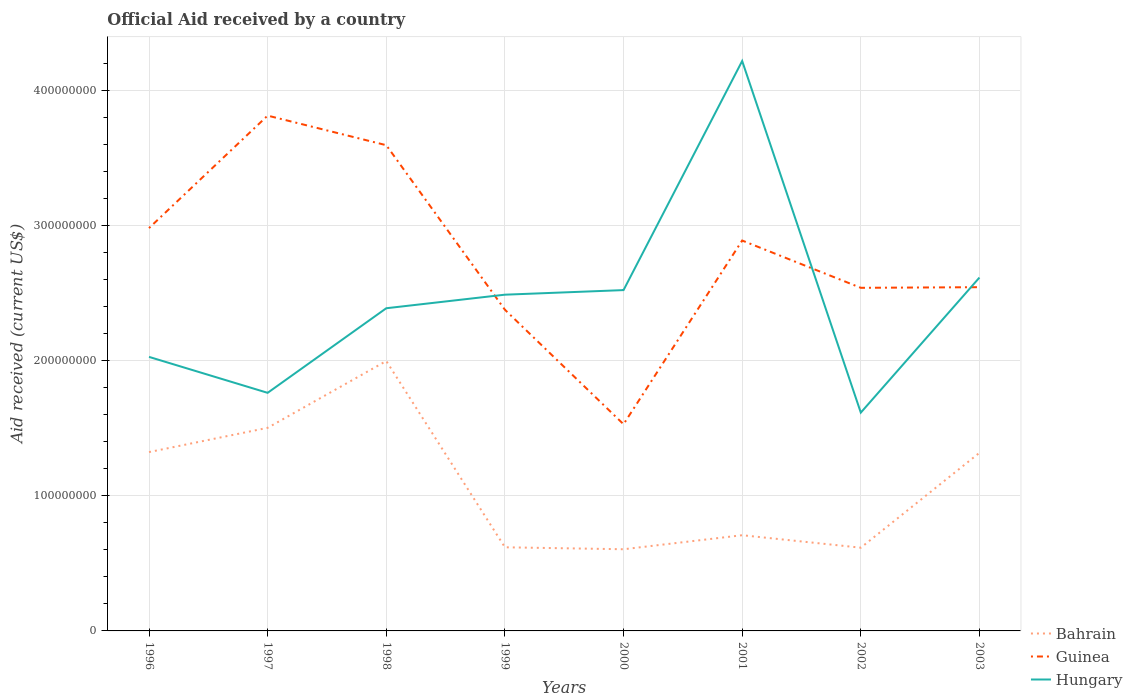How many different coloured lines are there?
Give a very brief answer. 3. Is the number of lines equal to the number of legend labels?
Give a very brief answer. Yes. Across all years, what is the maximum net official aid received in Guinea?
Give a very brief answer. 1.53e+08. In which year was the net official aid received in Guinea maximum?
Provide a short and direct response. 2000. What is the total net official aid received in Guinea in the graph?
Ensure brevity in your answer.  6.04e+07. What is the difference between the highest and the second highest net official aid received in Bahrain?
Make the answer very short. 1.39e+08. How many years are there in the graph?
Offer a very short reply. 8. What is the difference between two consecutive major ticks on the Y-axis?
Keep it short and to the point. 1.00e+08. Are the values on the major ticks of Y-axis written in scientific E-notation?
Make the answer very short. No. How many legend labels are there?
Offer a very short reply. 3. How are the legend labels stacked?
Offer a very short reply. Vertical. What is the title of the graph?
Your answer should be very brief. Official Aid received by a country. Does "New Caledonia" appear as one of the legend labels in the graph?
Ensure brevity in your answer.  No. What is the label or title of the Y-axis?
Provide a short and direct response. Aid received (current US$). What is the Aid received (current US$) of Bahrain in 1996?
Offer a terse response. 1.32e+08. What is the Aid received (current US$) of Guinea in 1996?
Your answer should be very brief. 2.98e+08. What is the Aid received (current US$) in Hungary in 1996?
Make the answer very short. 2.03e+08. What is the Aid received (current US$) of Bahrain in 1997?
Provide a succinct answer. 1.50e+08. What is the Aid received (current US$) of Guinea in 1997?
Keep it short and to the point. 3.81e+08. What is the Aid received (current US$) in Hungary in 1997?
Provide a short and direct response. 1.76e+08. What is the Aid received (current US$) in Bahrain in 1998?
Your response must be concise. 2.00e+08. What is the Aid received (current US$) in Guinea in 1998?
Offer a terse response. 3.59e+08. What is the Aid received (current US$) of Hungary in 1998?
Make the answer very short. 2.39e+08. What is the Aid received (current US$) in Bahrain in 1999?
Keep it short and to the point. 6.19e+07. What is the Aid received (current US$) in Guinea in 1999?
Give a very brief answer. 2.38e+08. What is the Aid received (current US$) in Hungary in 1999?
Make the answer very short. 2.49e+08. What is the Aid received (current US$) in Bahrain in 2000?
Your answer should be very brief. 6.04e+07. What is the Aid received (current US$) in Guinea in 2000?
Your answer should be very brief. 1.53e+08. What is the Aid received (current US$) in Hungary in 2000?
Your answer should be very brief. 2.52e+08. What is the Aid received (current US$) in Bahrain in 2001?
Keep it short and to the point. 7.08e+07. What is the Aid received (current US$) in Guinea in 2001?
Keep it short and to the point. 2.89e+08. What is the Aid received (current US$) in Hungary in 2001?
Provide a short and direct response. 4.22e+08. What is the Aid received (current US$) in Bahrain in 2002?
Your response must be concise. 6.16e+07. What is the Aid received (current US$) of Guinea in 2002?
Provide a succinct answer. 2.54e+08. What is the Aid received (current US$) in Hungary in 2002?
Make the answer very short. 1.62e+08. What is the Aid received (current US$) in Bahrain in 2003?
Offer a very short reply. 1.32e+08. What is the Aid received (current US$) of Guinea in 2003?
Offer a terse response. 2.54e+08. What is the Aid received (current US$) in Hungary in 2003?
Your response must be concise. 2.61e+08. Across all years, what is the maximum Aid received (current US$) in Bahrain?
Provide a succinct answer. 2.00e+08. Across all years, what is the maximum Aid received (current US$) in Guinea?
Offer a very short reply. 3.81e+08. Across all years, what is the maximum Aid received (current US$) in Hungary?
Your answer should be very brief. 4.22e+08. Across all years, what is the minimum Aid received (current US$) in Bahrain?
Ensure brevity in your answer.  6.04e+07. Across all years, what is the minimum Aid received (current US$) of Guinea?
Your response must be concise. 1.53e+08. Across all years, what is the minimum Aid received (current US$) of Hungary?
Provide a short and direct response. 1.62e+08. What is the total Aid received (current US$) in Bahrain in the graph?
Ensure brevity in your answer.  8.69e+08. What is the total Aid received (current US$) in Guinea in the graph?
Offer a terse response. 2.23e+09. What is the total Aid received (current US$) of Hungary in the graph?
Your answer should be compact. 1.96e+09. What is the difference between the Aid received (current US$) in Bahrain in 1996 and that in 1997?
Make the answer very short. -1.80e+07. What is the difference between the Aid received (current US$) of Guinea in 1996 and that in 1997?
Your response must be concise. -8.32e+07. What is the difference between the Aid received (current US$) of Hungary in 1996 and that in 1997?
Keep it short and to the point. 2.66e+07. What is the difference between the Aid received (current US$) in Bahrain in 1996 and that in 1998?
Give a very brief answer. -6.74e+07. What is the difference between the Aid received (current US$) in Guinea in 1996 and that in 1998?
Give a very brief answer. -6.13e+07. What is the difference between the Aid received (current US$) in Hungary in 1996 and that in 1998?
Give a very brief answer. -3.60e+07. What is the difference between the Aid received (current US$) in Bahrain in 1996 and that in 1999?
Give a very brief answer. 7.04e+07. What is the difference between the Aid received (current US$) in Guinea in 1996 and that in 1999?
Ensure brevity in your answer.  6.04e+07. What is the difference between the Aid received (current US$) of Hungary in 1996 and that in 1999?
Your answer should be compact. -4.60e+07. What is the difference between the Aid received (current US$) of Bahrain in 1996 and that in 2000?
Offer a terse response. 7.19e+07. What is the difference between the Aid received (current US$) of Guinea in 1996 and that in 2000?
Make the answer very short. 1.45e+08. What is the difference between the Aid received (current US$) in Hungary in 1996 and that in 2000?
Provide a short and direct response. -4.94e+07. What is the difference between the Aid received (current US$) of Bahrain in 1996 and that in 2001?
Make the answer very short. 6.15e+07. What is the difference between the Aid received (current US$) in Guinea in 1996 and that in 2001?
Offer a very short reply. 9.21e+06. What is the difference between the Aid received (current US$) of Hungary in 1996 and that in 2001?
Provide a succinct answer. -2.19e+08. What is the difference between the Aid received (current US$) in Bahrain in 1996 and that in 2002?
Offer a terse response. 7.07e+07. What is the difference between the Aid received (current US$) in Guinea in 1996 and that in 2002?
Make the answer very short. 4.42e+07. What is the difference between the Aid received (current US$) of Hungary in 1996 and that in 2002?
Give a very brief answer. 4.12e+07. What is the difference between the Aid received (current US$) of Guinea in 1996 and that in 2003?
Your answer should be very brief. 4.37e+07. What is the difference between the Aid received (current US$) of Hungary in 1996 and that in 2003?
Your response must be concise. -5.87e+07. What is the difference between the Aid received (current US$) in Bahrain in 1997 and that in 1998?
Provide a short and direct response. -4.94e+07. What is the difference between the Aid received (current US$) in Guinea in 1997 and that in 1998?
Make the answer very short. 2.19e+07. What is the difference between the Aid received (current US$) in Hungary in 1997 and that in 1998?
Offer a terse response. -6.26e+07. What is the difference between the Aid received (current US$) of Bahrain in 1997 and that in 1999?
Give a very brief answer. 8.84e+07. What is the difference between the Aid received (current US$) of Guinea in 1997 and that in 1999?
Keep it short and to the point. 1.44e+08. What is the difference between the Aid received (current US$) of Hungary in 1997 and that in 1999?
Make the answer very short. -7.26e+07. What is the difference between the Aid received (current US$) in Bahrain in 1997 and that in 2000?
Keep it short and to the point. 8.98e+07. What is the difference between the Aid received (current US$) in Guinea in 1997 and that in 2000?
Give a very brief answer. 2.28e+08. What is the difference between the Aid received (current US$) of Hungary in 1997 and that in 2000?
Provide a short and direct response. -7.60e+07. What is the difference between the Aid received (current US$) in Bahrain in 1997 and that in 2001?
Keep it short and to the point. 7.95e+07. What is the difference between the Aid received (current US$) in Guinea in 1997 and that in 2001?
Provide a succinct answer. 9.24e+07. What is the difference between the Aid received (current US$) in Hungary in 1997 and that in 2001?
Offer a terse response. -2.46e+08. What is the difference between the Aid received (current US$) of Bahrain in 1997 and that in 2002?
Your response must be concise. 8.87e+07. What is the difference between the Aid received (current US$) in Guinea in 1997 and that in 2002?
Your answer should be very brief. 1.27e+08. What is the difference between the Aid received (current US$) in Hungary in 1997 and that in 2002?
Ensure brevity in your answer.  1.46e+07. What is the difference between the Aid received (current US$) in Bahrain in 1997 and that in 2003?
Your answer should be very brief. 1.85e+07. What is the difference between the Aid received (current US$) of Guinea in 1997 and that in 2003?
Offer a terse response. 1.27e+08. What is the difference between the Aid received (current US$) of Hungary in 1997 and that in 2003?
Your answer should be very brief. -8.53e+07. What is the difference between the Aid received (current US$) in Bahrain in 1998 and that in 1999?
Offer a terse response. 1.38e+08. What is the difference between the Aid received (current US$) of Guinea in 1998 and that in 1999?
Give a very brief answer. 1.22e+08. What is the difference between the Aid received (current US$) in Hungary in 1998 and that in 1999?
Your answer should be very brief. -1.00e+07. What is the difference between the Aid received (current US$) in Bahrain in 1998 and that in 2000?
Provide a succinct answer. 1.39e+08. What is the difference between the Aid received (current US$) of Guinea in 1998 and that in 2000?
Keep it short and to the point. 2.06e+08. What is the difference between the Aid received (current US$) of Hungary in 1998 and that in 2000?
Make the answer very short. -1.34e+07. What is the difference between the Aid received (current US$) in Bahrain in 1998 and that in 2001?
Keep it short and to the point. 1.29e+08. What is the difference between the Aid received (current US$) of Guinea in 1998 and that in 2001?
Give a very brief answer. 7.05e+07. What is the difference between the Aid received (current US$) of Hungary in 1998 and that in 2001?
Make the answer very short. -1.83e+08. What is the difference between the Aid received (current US$) of Bahrain in 1998 and that in 2002?
Provide a short and direct response. 1.38e+08. What is the difference between the Aid received (current US$) in Guinea in 1998 and that in 2002?
Offer a very short reply. 1.06e+08. What is the difference between the Aid received (current US$) in Hungary in 1998 and that in 2002?
Your answer should be compact. 7.72e+07. What is the difference between the Aid received (current US$) of Bahrain in 1998 and that in 2003?
Your response must be concise. 6.80e+07. What is the difference between the Aid received (current US$) in Guinea in 1998 and that in 2003?
Provide a succinct answer. 1.05e+08. What is the difference between the Aid received (current US$) of Hungary in 1998 and that in 2003?
Offer a terse response. -2.27e+07. What is the difference between the Aid received (current US$) in Bahrain in 1999 and that in 2000?
Offer a very short reply. 1.45e+06. What is the difference between the Aid received (current US$) in Guinea in 1999 and that in 2000?
Your answer should be very brief. 8.47e+07. What is the difference between the Aid received (current US$) in Hungary in 1999 and that in 2000?
Make the answer very short. -3.39e+06. What is the difference between the Aid received (current US$) in Bahrain in 1999 and that in 2001?
Provide a short and direct response. -8.93e+06. What is the difference between the Aid received (current US$) in Guinea in 1999 and that in 2001?
Provide a short and direct response. -5.12e+07. What is the difference between the Aid received (current US$) of Hungary in 1999 and that in 2001?
Ensure brevity in your answer.  -1.73e+08. What is the difference between the Aid received (current US$) in Bahrain in 1999 and that in 2002?
Make the answer very short. 3.00e+05. What is the difference between the Aid received (current US$) of Guinea in 1999 and that in 2002?
Ensure brevity in your answer.  -1.62e+07. What is the difference between the Aid received (current US$) of Hungary in 1999 and that in 2002?
Keep it short and to the point. 8.73e+07. What is the difference between the Aid received (current US$) in Bahrain in 1999 and that in 2003?
Keep it short and to the point. -6.99e+07. What is the difference between the Aid received (current US$) in Guinea in 1999 and that in 2003?
Ensure brevity in your answer.  -1.67e+07. What is the difference between the Aid received (current US$) of Hungary in 1999 and that in 2003?
Keep it short and to the point. -1.27e+07. What is the difference between the Aid received (current US$) in Bahrain in 2000 and that in 2001?
Ensure brevity in your answer.  -1.04e+07. What is the difference between the Aid received (current US$) in Guinea in 2000 and that in 2001?
Keep it short and to the point. -1.36e+08. What is the difference between the Aid received (current US$) in Hungary in 2000 and that in 2001?
Your answer should be very brief. -1.70e+08. What is the difference between the Aid received (current US$) in Bahrain in 2000 and that in 2002?
Make the answer very short. -1.15e+06. What is the difference between the Aid received (current US$) in Guinea in 2000 and that in 2002?
Make the answer very short. -1.01e+08. What is the difference between the Aid received (current US$) of Hungary in 2000 and that in 2002?
Ensure brevity in your answer.  9.06e+07. What is the difference between the Aid received (current US$) of Bahrain in 2000 and that in 2003?
Provide a succinct answer. -7.13e+07. What is the difference between the Aid received (current US$) in Guinea in 2000 and that in 2003?
Provide a succinct answer. -1.01e+08. What is the difference between the Aid received (current US$) of Hungary in 2000 and that in 2003?
Your answer should be very brief. -9.28e+06. What is the difference between the Aid received (current US$) in Bahrain in 2001 and that in 2002?
Provide a short and direct response. 9.23e+06. What is the difference between the Aid received (current US$) of Guinea in 2001 and that in 2002?
Your response must be concise. 3.50e+07. What is the difference between the Aid received (current US$) of Hungary in 2001 and that in 2002?
Provide a succinct answer. 2.60e+08. What is the difference between the Aid received (current US$) of Bahrain in 2001 and that in 2003?
Give a very brief answer. -6.10e+07. What is the difference between the Aid received (current US$) of Guinea in 2001 and that in 2003?
Keep it short and to the point. 3.45e+07. What is the difference between the Aid received (current US$) of Hungary in 2001 and that in 2003?
Provide a succinct answer. 1.60e+08. What is the difference between the Aid received (current US$) of Bahrain in 2002 and that in 2003?
Offer a very short reply. -7.02e+07. What is the difference between the Aid received (current US$) in Guinea in 2002 and that in 2003?
Your response must be concise. -4.70e+05. What is the difference between the Aid received (current US$) of Hungary in 2002 and that in 2003?
Ensure brevity in your answer.  -9.99e+07. What is the difference between the Aid received (current US$) in Bahrain in 1996 and the Aid received (current US$) in Guinea in 1997?
Ensure brevity in your answer.  -2.49e+08. What is the difference between the Aid received (current US$) in Bahrain in 1996 and the Aid received (current US$) in Hungary in 1997?
Offer a terse response. -4.38e+07. What is the difference between the Aid received (current US$) in Guinea in 1996 and the Aid received (current US$) in Hungary in 1997?
Make the answer very short. 1.22e+08. What is the difference between the Aid received (current US$) in Bahrain in 1996 and the Aid received (current US$) in Guinea in 1998?
Ensure brevity in your answer.  -2.27e+08. What is the difference between the Aid received (current US$) in Bahrain in 1996 and the Aid received (current US$) in Hungary in 1998?
Make the answer very short. -1.06e+08. What is the difference between the Aid received (current US$) of Guinea in 1996 and the Aid received (current US$) of Hungary in 1998?
Your answer should be very brief. 5.93e+07. What is the difference between the Aid received (current US$) in Bahrain in 1996 and the Aid received (current US$) in Guinea in 1999?
Provide a short and direct response. -1.05e+08. What is the difference between the Aid received (current US$) in Bahrain in 1996 and the Aid received (current US$) in Hungary in 1999?
Give a very brief answer. -1.16e+08. What is the difference between the Aid received (current US$) in Guinea in 1996 and the Aid received (current US$) in Hungary in 1999?
Give a very brief answer. 4.93e+07. What is the difference between the Aid received (current US$) of Bahrain in 1996 and the Aid received (current US$) of Guinea in 2000?
Your response must be concise. -2.06e+07. What is the difference between the Aid received (current US$) in Bahrain in 1996 and the Aid received (current US$) in Hungary in 2000?
Ensure brevity in your answer.  -1.20e+08. What is the difference between the Aid received (current US$) of Guinea in 1996 and the Aid received (current US$) of Hungary in 2000?
Ensure brevity in your answer.  4.59e+07. What is the difference between the Aid received (current US$) in Bahrain in 1996 and the Aid received (current US$) in Guinea in 2001?
Provide a short and direct response. -1.57e+08. What is the difference between the Aid received (current US$) of Bahrain in 1996 and the Aid received (current US$) of Hungary in 2001?
Provide a short and direct response. -2.89e+08. What is the difference between the Aid received (current US$) of Guinea in 1996 and the Aid received (current US$) of Hungary in 2001?
Offer a terse response. -1.24e+08. What is the difference between the Aid received (current US$) of Bahrain in 1996 and the Aid received (current US$) of Guinea in 2002?
Ensure brevity in your answer.  -1.22e+08. What is the difference between the Aid received (current US$) of Bahrain in 1996 and the Aid received (current US$) of Hungary in 2002?
Offer a very short reply. -2.92e+07. What is the difference between the Aid received (current US$) of Guinea in 1996 and the Aid received (current US$) of Hungary in 2002?
Keep it short and to the point. 1.37e+08. What is the difference between the Aid received (current US$) in Bahrain in 1996 and the Aid received (current US$) in Guinea in 2003?
Give a very brief answer. -1.22e+08. What is the difference between the Aid received (current US$) of Bahrain in 1996 and the Aid received (current US$) of Hungary in 2003?
Give a very brief answer. -1.29e+08. What is the difference between the Aid received (current US$) of Guinea in 1996 and the Aid received (current US$) of Hungary in 2003?
Offer a very short reply. 3.66e+07. What is the difference between the Aid received (current US$) in Bahrain in 1997 and the Aid received (current US$) in Guinea in 1998?
Your answer should be compact. -2.09e+08. What is the difference between the Aid received (current US$) in Bahrain in 1997 and the Aid received (current US$) in Hungary in 1998?
Provide a short and direct response. -8.85e+07. What is the difference between the Aid received (current US$) in Guinea in 1997 and the Aid received (current US$) in Hungary in 1998?
Provide a succinct answer. 1.43e+08. What is the difference between the Aid received (current US$) of Bahrain in 1997 and the Aid received (current US$) of Guinea in 1999?
Make the answer very short. -8.74e+07. What is the difference between the Aid received (current US$) in Bahrain in 1997 and the Aid received (current US$) in Hungary in 1999?
Provide a short and direct response. -9.85e+07. What is the difference between the Aid received (current US$) of Guinea in 1997 and the Aid received (current US$) of Hungary in 1999?
Give a very brief answer. 1.32e+08. What is the difference between the Aid received (current US$) in Bahrain in 1997 and the Aid received (current US$) in Guinea in 2000?
Offer a terse response. -2.65e+06. What is the difference between the Aid received (current US$) in Bahrain in 1997 and the Aid received (current US$) in Hungary in 2000?
Your answer should be very brief. -1.02e+08. What is the difference between the Aid received (current US$) in Guinea in 1997 and the Aid received (current US$) in Hungary in 2000?
Provide a succinct answer. 1.29e+08. What is the difference between the Aid received (current US$) of Bahrain in 1997 and the Aid received (current US$) of Guinea in 2001?
Make the answer very short. -1.39e+08. What is the difference between the Aid received (current US$) in Bahrain in 1997 and the Aid received (current US$) in Hungary in 2001?
Keep it short and to the point. -2.71e+08. What is the difference between the Aid received (current US$) of Guinea in 1997 and the Aid received (current US$) of Hungary in 2001?
Give a very brief answer. -4.04e+07. What is the difference between the Aid received (current US$) in Bahrain in 1997 and the Aid received (current US$) in Guinea in 2002?
Your answer should be very brief. -1.04e+08. What is the difference between the Aid received (current US$) of Bahrain in 1997 and the Aid received (current US$) of Hungary in 2002?
Ensure brevity in your answer.  -1.12e+07. What is the difference between the Aid received (current US$) of Guinea in 1997 and the Aid received (current US$) of Hungary in 2002?
Keep it short and to the point. 2.20e+08. What is the difference between the Aid received (current US$) in Bahrain in 1997 and the Aid received (current US$) in Guinea in 2003?
Your answer should be compact. -1.04e+08. What is the difference between the Aid received (current US$) of Bahrain in 1997 and the Aid received (current US$) of Hungary in 2003?
Your answer should be very brief. -1.11e+08. What is the difference between the Aid received (current US$) in Guinea in 1997 and the Aid received (current US$) in Hungary in 2003?
Offer a terse response. 1.20e+08. What is the difference between the Aid received (current US$) of Bahrain in 1998 and the Aid received (current US$) of Guinea in 1999?
Offer a very short reply. -3.79e+07. What is the difference between the Aid received (current US$) in Bahrain in 1998 and the Aid received (current US$) in Hungary in 1999?
Give a very brief answer. -4.91e+07. What is the difference between the Aid received (current US$) of Guinea in 1998 and the Aid received (current US$) of Hungary in 1999?
Offer a terse response. 1.11e+08. What is the difference between the Aid received (current US$) of Bahrain in 1998 and the Aid received (current US$) of Guinea in 2000?
Your answer should be very brief. 4.68e+07. What is the difference between the Aid received (current US$) of Bahrain in 1998 and the Aid received (current US$) of Hungary in 2000?
Your response must be concise. -5.24e+07. What is the difference between the Aid received (current US$) of Guinea in 1998 and the Aid received (current US$) of Hungary in 2000?
Provide a short and direct response. 1.07e+08. What is the difference between the Aid received (current US$) in Bahrain in 1998 and the Aid received (current US$) in Guinea in 2001?
Your answer should be very brief. -8.91e+07. What is the difference between the Aid received (current US$) of Bahrain in 1998 and the Aid received (current US$) of Hungary in 2001?
Give a very brief answer. -2.22e+08. What is the difference between the Aid received (current US$) in Guinea in 1998 and the Aid received (current US$) in Hungary in 2001?
Give a very brief answer. -6.23e+07. What is the difference between the Aid received (current US$) in Bahrain in 1998 and the Aid received (current US$) in Guinea in 2002?
Your answer should be very brief. -5.41e+07. What is the difference between the Aid received (current US$) of Bahrain in 1998 and the Aid received (current US$) of Hungary in 2002?
Give a very brief answer. 3.82e+07. What is the difference between the Aid received (current US$) of Guinea in 1998 and the Aid received (current US$) of Hungary in 2002?
Offer a very short reply. 1.98e+08. What is the difference between the Aid received (current US$) in Bahrain in 1998 and the Aid received (current US$) in Guinea in 2003?
Offer a terse response. -5.46e+07. What is the difference between the Aid received (current US$) of Bahrain in 1998 and the Aid received (current US$) of Hungary in 2003?
Offer a terse response. -6.17e+07. What is the difference between the Aid received (current US$) of Guinea in 1998 and the Aid received (current US$) of Hungary in 2003?
Your answer should be very brief. 9.79e+07. What is the difference between the Aid received (current US$) of Bahrain in 1999 and the Aid received (current US$) of Guinea in 2000?
Give a very brief answer. -9.10e+07. What is the difference between the Aid received (current US$) in Bahrain in 1999 and the Aid received (current US$) in Hungary in 2000?
Offer a terse response. -1.90e+08. What is the difference between the Aid received (current US$) in Guinea in 1999 and the Aid received (current US$) in Hungary in 2000?
Provide a succinct answer. -1.45e+07. What is the difference between the Aid received (current US$) of Bahrain in 1999 and the Aid received (current US$) of Guinea in 2001?
Your response must be concise. -2.27e+08. What is the difference between the Aid received (current US$) of Bahrain in 1999 and the Aid received (current US$) of Hungary in 2001?
Ensure brevity in your answer.  -3.60e+08. What is the difference between the Aid received (current US$) of Guinea in 1999 and the Aid received (current US$) of Hungary in 2001?
Provide a short and direct response. -1.84e+08. What is the difference between the Aid received (current US$) in Bahrain in 1999 and the Aid received (current US$) in Guinea in 2002?
Your response must be concise. -1.92e+08. What is the difference between the Aid received (current US$) of Bahrain in 1999 and the Aid received (current US$) of Hungary in 2002?
Ensure brevity in your answer.  -9.96e+07. What is the difference between the Aid received (current US$) in Guinea in 1999 and the Aid received (current US$) in Hungary in 2002?
Your answer should be very brief. 7.61e+07. What is the difference between the Aid received (current US$) of Bahrain in 1999 and the Aid received (current US$) of Guinea in 2003?
Provide a short and direct response. -1.92e+08. What is the difference between the Aid received (current US$) in Bahrain in 1999 and the Aid received (current US$) in Hungary in 2003?
Provide a succinct answer. -2.00e+08. What is the difference between the Aid received (current US$) of Guinea in 1999 and the Aid received (current US$) of Hungary in 2003?
Keep it short and to the point. -2.38e+07. What is the difference between the Aid received (current US$) of Bahrain in 2000 and the Aid received (current US$) of Guinea in 2001?
Give a very brief answer. -2.28e+08. What is the difference between the Aid received (current US$) in Bahrain in 2000 and the Aid received (current US$) in Hungary in 2001?
Your response must be concise. -3.61e+08. What is the difference between the Aid received (current US$) of Guinea in 2000 and the Aid received (current US$) of Hungary in 2001?
Offer a very short reply. -2.69e+08. What is the difference between the Aid received (current US$) in Bahrain in 2000 and the Aid received (current US$) in Guinea in 2002?
Ensure brevity in your answer.  -1.93e+08. What is the difference between the Aid received (current US$) in Bahrain in 2000 and the Aid received (current US$) in Hungary in 2002?
Offer a very short reply. -1.01e+08. What is the difference between the Aid received (current US$) in Guinea in 2000 and the Aid received (current US$) in Hungary in 2002?
Keep it short and to the point. -8.59e+06. What is the difference between the Aid received (current US$) of Bahrain in 2000 and the Aid received (current US$) of Guinea in 2003?
Make the answer very short. -1.94e+08. What is the difference between the Aid received (current US$) of Bahrain in 2000 and the Aid received (current US$) of Hungary in 2003?
Your answer should be very brief. -2.01e+08. What is the difference between the Aid received (current US$) of Guinea in 2000 and the Aid received (current US$) of Hungary in 2003?
Make the answer very short. -1.09e+08. What is the difference between the Aid received (current US$) of Bahrain in 2001 and the Aid received (current US$) of Guinea in 2002?
Offer a terse response. -1.83e+08. What is the difference between the Aid received (current US$) of Bahrain in 2001 and the Aid received (current US$) of Hungary in 2002?
Make the answer very short. -9.07e+07. What is the difference between the Aid received (current US$) of Guinea in 2001 and the Aid received (current US$) of Hungary in 2002?
Your response must be concise. 1.27e+08. What is the difference between the Aid received (current US$) of Bahrain in 2001 and the Aid received (current US$) of Guinea in 2003?
Provide a short and direct response. -1.84e+08. What is the difference between the Aid received (current US$) in Bahrain in 2001 and the Aid received (current US$) in Hungary in 2003?
Provide a succinct answer. -1.91e+08. What is the difference between the Aid received (current US$) in Guinea in 2001 and the Aid received (current US$) in Hungary in 2003?
Give a very brief answer. 2.74e+07. What is the difference between the Aid received (current US$) in Bahrain in 2002 and the Aid received (current US$) in Guinea in 2003?
Keep it short and to the point. -1.93e+08. What is the difference between the Aid received (current US$) in Bahrain in 2002 and the Aid received (current US$) in Hungary in 2003?
Offer a terse response. -2.00e+08. What is the difference between the Aid received (current US$) in Guinea in 2002 and the Aid received (current US$) in Hungary in 2003?
Give a very brief answer. -7.59e+06. What is the average Aid received (current US$) in Bahrain per year?
Your answer should be very brief. 1.09e+08. What is the average Aid received (current US$) in Guinea per year?
Provide a succinct answer. 2.78e+08. What is the average Aid received (current US$) of Hungary per year?
Provide a succinct answer. 2.45e+08. In the year 1996, what is the difference between the Aid received (current US$) of Bahrain and Aid received (current US$) of Guinea?
Your answer should be compact. -1.66e+08. In the year 1996, what is the difference between the Aid received (current US$) in Bahrain and Aid received (current US$) in Hungary?
Your response must be concise. -7.04e+07. In the year 1996, what is the difference between the Aid received (current US$) in Guinea and Aid received (current US$) in Hungary?
Offer a terse response. 9.53e+07. In the year 1997, what is the difference between the Aid received (current US$) of Bahrain and Aid received (current US$) of Guinea?
Keep it short and to the point. -2.31e+08. In the year 1997, what is the difference between the Aid received (current US$) in Bahrain and Aid received (current US$) in Hungary?
Offer a very short reply. -2.59e+07. In the year 1997, what is the difference between the Aid received (current US$) of Guinea and Aid received (current US$) of Hungary?
Provide a short and direct response. 2.05e+08. In the year 1998, what is the difference between the Aid received (current US$) in Bahrain and Aid received (current US$) in Guinea?
Provide a short and direct response. -1.60e+08. In the year 1998, what is the difference between the Aid received (current US$) in Bahrain and Aid received (current US$) in Hungary?
Provide a succinct answer. -3.90e+07. In the year 1998, what is the difference between the Aid received (current US$) of Guinea and Aid received (current US$) of Hungary?
Offer a terse response. 1.21e+08. In the year 1999, what is the difference between the Aid received (current US$) of Bahrain and Aid received (current US$) of Guinea?
Give a very brief answer. -1.76e+08. In the year 1999, what is the difference between the Aid received (current US$) of Bahrain and Aid received (current US$) of Hungary?
Keep it short and to the point. -1.87e+08. In the year 1999, what is the difference between the Aid received (current US$) in Guinea and Aid received (current US$) in Hungary?
Keep it short and to the point. -1.11e+07. In the year 2000, what is the difference between the Aid received (current US$) of Bahrain and Aid received (current US$) of Guinea?
Offer a terse response. -9.25e+07. In the year 2000, what is the difference between the Aid received (current US$) in Bahrain and Aid received (current US$) in Hungary?
Offer a very short reply. -1.92e+08. In the year 2000, what is the difference between the Aid received (current US$) of Guinea and Aid received (current US$) of Hungary?
Provide a succinct answer. -9.92e+07. In the year 2001, what is the difference between the Aid received (current US$) in Bahrain and Aid received (current US$) in Guinea?
Ensure brevity in your answer.  -2.18e+08. In the year 2001, what is the difference between the Aid received (current US$) of Bahrain and Aid received (current US$) of Hungary?
Offer a very short reply. -3.51e+08. In the year 2001, what is the difference between the Aid received (current US$) in Guinea and Aid received (current US$) in Hungary?
Provide a succinct answer. -1.33e+08. In the year 2002, what is the difference between the Aid received (current US$) in Bahrain and Aid received (current US$) in Guinea?
Provide a succinct answer. -1.92e+08. In the year 2002, what is the difference between the Aid received (current US$) of Bahrain and Aid received (current US$) of Hungary?
Give a very brief answer. -9.99e+07. In the year 2002, what is the difference between the Aid received (current US$) in Guinea and Aid received (current US$) in Hungary?
Offer a very short reply. 9.23e+07. In the year 2003, what is the difference between the Aid received (current US$) in Bahrain and Aid received (current US$) in Guinea?
Ensure brevity in your answer.  -1.23e+08. In the year 2003, what is the difference between the Aid received (current US$) of Bahrain and Aid received (current US$) of Hungary?
Ensure brevity in your answer.  -1.30e+08. In the year 2003, what is the difference between the Aid received (current US$) of Guinea and Aid received (current US$) of Hungary?
Make the answer very short. -7.12e+06. What is the ratio of the Aid received (current US$) of Bahrain in 1996 to that in 1997?
Keep it short and to the point. 0.88. What is the ratio of the Aid received (current US$) in Guinea in 1996 to that in 1997?
Give a very brief answer. 0.78. What is the ratio of the Aid received (current US$) in Hungary in 1996 to that in 1997?
Ensure brevity in your answer.  1.15. What is the ratio of the Aid received (current US$) of Bahrain in 1996 to that in 1998?
Provide a short and direct response. 0.66. What is the ratio of the Aid received (current US$) in Guinea in 1996 to that in 1998?
Your response must be concise. 0.83. What is the ratio of the Aid received (current US$) of Hungary in 1996 to that in 1998?
Your answer should be very brief. 0.85. What is the ratio of the Aid received (current US$) in Bahrain in 1996 to that in 1999?
Ensure brevity in your answer.  2.14. What is the ratio of the Aid received (current US$) of Guinea in 1996 to that in 1999?
Provide a short and direct response. 1.25. What is the ratio of the Aid received (current US$) of Hungary in 1996 to that in 1999?
Offer a very short reply. 0.81. What is the ratio of the Aid received (current US$) of Bahrain in 1996 to that in 2000?
Ensure brevity in your answer.  2.19. What is the ratio of the Aid received (current US$) in Guinea in 1996 to that in 2000?
Offer a very short reply. 1.95. What is the ratio of the Aid received (current US$) of Hungary in 1996 to that in 2000?
Your response must be concise. 0.8. What is the ratio of the Aid received (current US$) in Bahrain in 1996 to that in 2001?
Your response must be concise. 1.87. What is the ratio of the Aid received (current US$) in Guinea in 1996 to that in 2001?
Ensure brevity in your answer.  1.03. What is the ratio of the Aid received (current US$) in Hungary in 1996 to that in 2001?
Offer a terse response. 0.48. What is the ratio of the Aid received (current US$) in Bahrain in 1996 to that in 2002?
Your response must be concise. 2.15. What is the ratio of the Aid received (current US$) in Guinea in 1996 to that in 2002?
Your answer should be compact. 1.17. What is the ratio of the Aid received (current US$) of Hungary in 1996 to that in 2002?
Give a very brief answer. 1.26. What is the ratio of the Aid received (current US$) in Guinea in 1996 to that in 2003?
Your answer should be very brief. 1.17. What is the ratio of the Aid received (current US$) of Hungary in 1996 to that in 2003?
Offer a very short reply. 0.78. What is the ratio of the Aid received (current US$) in Bahrain in 1997 to that in 1998?
Ensure brevity in your answer.  0.75. What is the ratio of the Aid received (current US$) of Guinea in 1997 to that in 1998?
Give a very brief answer. 1.06. What is the ratio of the Aid received (current US$) of Hungary in 1997 to that in 1998?
Provide a short and direct response. 0.74. What is the ratio of the Aid received (current US$) of Bahrain in 1997 to that in 1999?
Ensure brevity in your answer.  2.43. What is the ratio of the Aid received (current US$) of Guinea in 1997 to that in 1999?
Give a very brief answer. 1.6. What is the ratio of the Aid received (current US$) in Hungary in 1997 to that in 1999?
Provide a succinct answer. 0.71. What is the ratio of the Aid received (current US$) of Bahrain in 1997 to that in 2000?
Make the answer very short. 2.49. What is the ratio of the Aid received (current US$) of Guinea in 1997 to that in 2000?
Offer a very short reply. 2.49. What is the ratio of the Aid received (current US$) in Hungary in 1997 to that in 2000?
Make the answer very short. 0.7. What is the ratio of the Aid received (current US$) of Bahrain in 1997 to that in 2001?
Make the answer very short. 2.12. What is the ratio of the Aid received (current US$) in Guinea in 1997 to that in 2001?
Your answer should be compact. 1.32. What is the ratio of the Aid received (current US$) of Hungary in 1997 to that in 2001?
Offer a very short reply. 0.42. What is the ratio of the Aid received (current US$) of Bahrain in 1997 to that in 2002?
Provide a succinct answer. 2.44. What is the ratio of the Aid received (current US$) of Guinea in 1997 to that in 2002?
Provide a succinct answer. 1.5. What is the ratio of the Aid received (current US$) of Hungary in 1997 to that in 2002?
Your response must be concise. 1.09. What is the ratio of the Aid received (current US$) of Bahrain in 1997 to that in 2003?
Ensure brevity in your answer.  1.14. What is the ratio of the Aid received (current US$) of Guinea in 1997 to that in 2003?
Make the answer very short. 1.5. What is the ratio of the Aid received (current US$) of Hungary in 1997 to that in 2003?
Make the answer very short. 0.67. What is the ratio of the Aid received (current US$) in Bahrain in 1998 to that in 1999?
Ensure brevity in your answer.  3.23. What is the ratio of the Aid received (current US$) of Guinea in 1998 to that in 1999?
Your response must be concise. 1.51. What is the ratio of the Aid received (current US$) in Hungary in 1998 to that in 1999?
Provide a short and direct response. 0.96. What is the ratio of the Aid received (current US$) in Bahrain in 1998 to that in 2000?
Provide a short and direct response. 3.31. What is the ratio of the Aid received (current US$) of Guinea in 1998 to that in 2000?
Your response must be concise. 2.35. What is the ratio of the Aid received (current US$) of Hungary in 1998 to that in 2000?
Offer a very short reply. 0.95. What is the ratio of the Aid received (current US$) of Bahrain in 1998 to that in 2001?
Make the answer very short. 2.82. What is the ratio of the Aid received (current US$) of Guinea in 1998 to that in 2001?
Your answer should be very brief. 1.24. What is the ratio of the Aid received (current US$) in Hungary in 1998 to that in 2001?
Your answer should be very brief. 0.57. What is the ratio of the Aid received (current US$) in Bahrain in 1998 to that in 2002?
Provide a succinct answer. 3.24. What is the ratio of the Aid received (current US$) in Guinea in 1998 to that in 2002?
Your response must be concise. 1.42. What is the ratio of the Aid received (current US$) in Hungary in 1998 to that in 2002?
Give a very brief answer. 1.48. What is the ratio of the Aid received (current US$) in Bahrain in 1998 to that in 2003?
Your answer should be compact. 1.52. What is the ratio of the Aid received (current US$) of Guinea in 1998 to that in 2003?
Your answer should be compact. 1.41. What is the ratio of the Aid received (current US$) in Hungary in 1998 to that in 2003?
Your response must be concise. 0.91. What is the ratio of the Aid received (current US$) of Bahrain in 1999 to that in 2000?
Provide a short and direct response. 1.02. What is the ratio of the Aid received (current US$) of Guinea in 1999 to that in 2000?
Provide a succinct answer. 1.55. What is the ratio of the Aid received (current US$) of Hungary in 1999 to that in 2000?
Keep it short and to the point. 0.99. What is the ratio of the Aid received (current US$) in Bahrain in 1999 to that in 2001?
Make the answer very short. 0.87. What is the ratio of the Aid received (current US$) in Guinea in 1999 to that in 2001?
Provide a short and direct response. 0.82. What is the ratio of the Aid received (current US$) of Hungary in 1999 to that in 2001?
Keep it short and to the point. 0.59. What is the ratio of the Aid received (current US$) of Bahrain in 1999 to that in 2002?
Provide a succinct answer. 1. What is the ratio of the Aid received (current US$) of Guinea in 1999 to that in 2002?
Offer a very short reply. 0.94. What is the ratio of the Aid received (current US$) in Hungary in 1999 to that in 2002?
Offer a very short reply. 1.54. What is the ratio of the Aid received (current US$) in Bahrain in 1999 to that in 2003?
Your answer should be compact. 0.47. What is the ratio of the Aid received (current US$) of Guinea in 1999 to that in 2003?
Make the answer very short. 0.93. What is the ratio of the Aid received (current US$) in Hungary in 1999 to that in 2003?
Keep it short and to the point. 0.95. What is the ratio of the Aid received (current US$) in Bahrain in 2000 to that in 2001?
Your response must be concise. 0.85. What is the ratio of the Aid received (current US$) in Guinea in 2000 to that in 2001?
Keep it short and to the point. 0.53. What is the ratio of the Aid received (current US$) of Hungary in 2000 to that in 2001?
Offer a very short reply. 0.6. What is the ratio of the Aid received (current US$) of Bahrain in 2000 to that in 2002?
Offer a very short reply. 0.98. What is the ratio of the Aid received (current US$) in Guinea in 2000 to that in 2002?
Keep it short and to the point. 0.6. What is the ratio of the Aid received (current US$) of Hungary in 2000 to that in 2002?
Offer a terse response. 1.56. What is the ratio of the Aid received (current US$) of Bahrain in 2000 to that in 2003?
Your answer should be very brief. 0.46. What is the ratio of the Aid received (current US$) in Guinea in 2000 to that in 2003?
Make the answer very short. 0.6. What is the ratio of the Aid received (current US$) in Hungary in 2000 to that in 2003?
Ensure brevity in your answer.  0.96. What is the ratio of the Aid received (current US$) in Bahrain in 2001 to that in 2002?
Provide a succinct answer. 1.15. What is the ratio of the Aid received (current US$) in Guinea in 2001 to that in 2002?
Make the answer very short. 1.14. What is the ratio of the Aid received (current US$) in Hungary in 2001 to that in 2002?
Your response must be concise. 2.61. What is the ratio of the Aid received (current US$) in Bahrain in 2001 to that in 2003?
Give a very brief answer. 0.54. What is the ratio of the Aid received (current US$) of Guinea in 2001 to that in 2003?
Your answer should be very brief. 1.14. What is the ratio of the Aid received (current US$) of Hungary in 2001 to that in 2003?
Your answer should be compact. 1.61. What is the ratio of the Aid received (current US$) in Bahrain in 2002 to that in 2003?
Offer a terse response. 0.47. What is the ratio of the Aid received (current US$) in Guinea in 2002 to that in 2003?
Your response must be concise. 1. What is the ratio of the Aid received (current US$) in Hungary in 2002 to that in 2003?
Keep it short and to the point. 0.62. What is the difference between the highest and the second highest Aid received (current US$) of Bahrain?
Make the answer very short. 4.94e+07. What is the difference between the highest and the second highest Aid received (current US$) in Guinea?
Offer a terse response. 2.19e+07. What is the difference between the highest and the second highest Aid received (current US$) in Hungary?
Your answer should be compact. 1.60e+08. What is the difference between the highest and the lowest Aid received (current US$) in Bahrain?
Give a very brief answer. 1.39e+08. What is the difference between the highest and the lowest Aid received (current US$) in Guinea?
Give a very brief answer. 2.28e+08. What is the difference between the highest and the lowest Aid received (current US$) in Hungary?
Provide a short and direct response. 2.60e+08. 